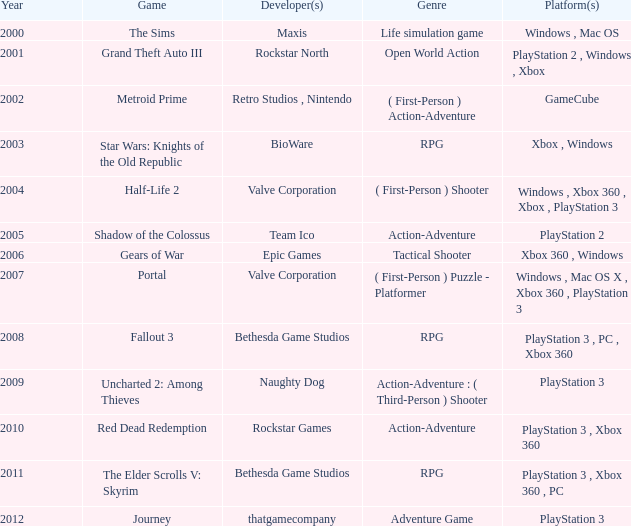What game was released in 2005? Shadow of the Colossus. 